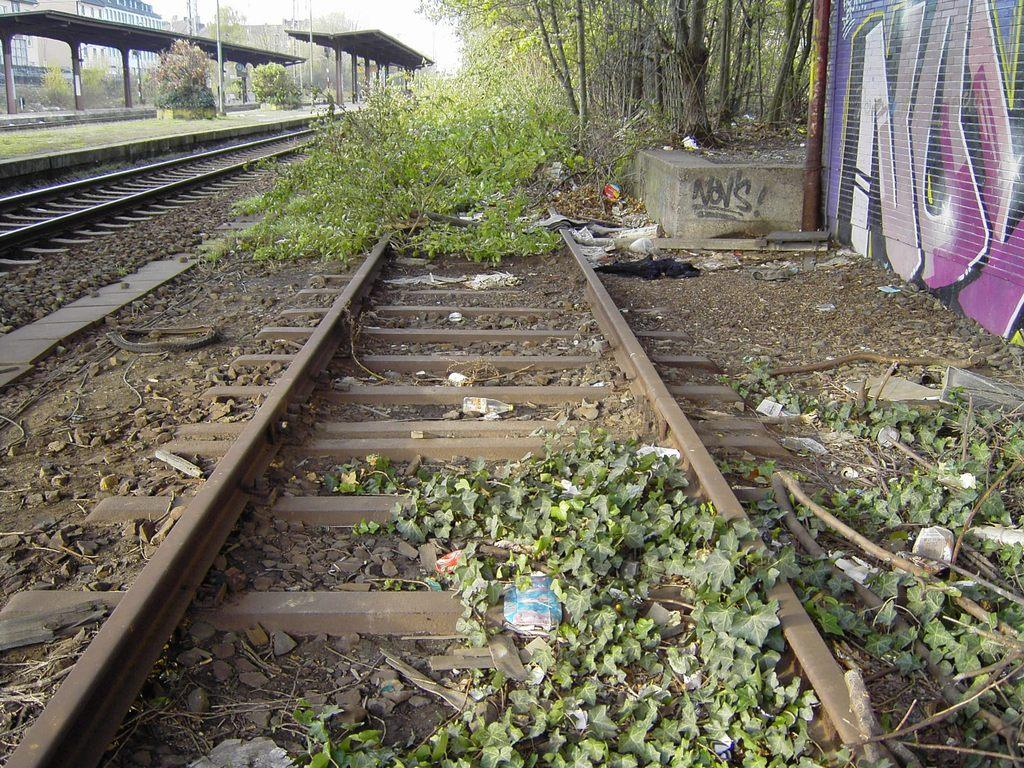What is located in the middle of the image? There are trees, plants, railway tracks, a wall, and grass in the middle of the image. What type of transportation infrastructure is present in the image? Railway tracks and platforms are present in the middle of the image. What can be seen in the background of the image? There are buildings and the sky visible in the background of the image. How many bones can be seen in the image? There are no bones present in the image. Are there any horses visible in the image? There are no horses present in the image. 